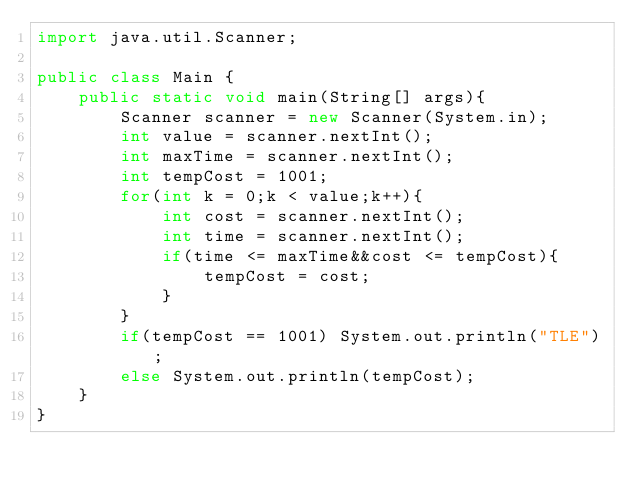<code> <loc_0><loc_0><loc_500><loc_500><_Java_>import java.util.Scanner;

public class Main {
    public static void main(String[] args){
        Scanner scanner = new Scanner(System.in);
        int value = scanner.nextInt();
        int maxTime = scanner.nextInt();
        int tempCost = 1001;
        for(int k = 0;k < value;k++){
            int cost = scanner.nextInt();
            int time = scanner.nextInt();
            if(time <= maxTime&&cost <= tempCost){
                tempCost = cost;
            }
        }
        if(tempCost == 1001) System.out.println("TLE");
        else System.out.println(tempCost);
    }
}
</code> 